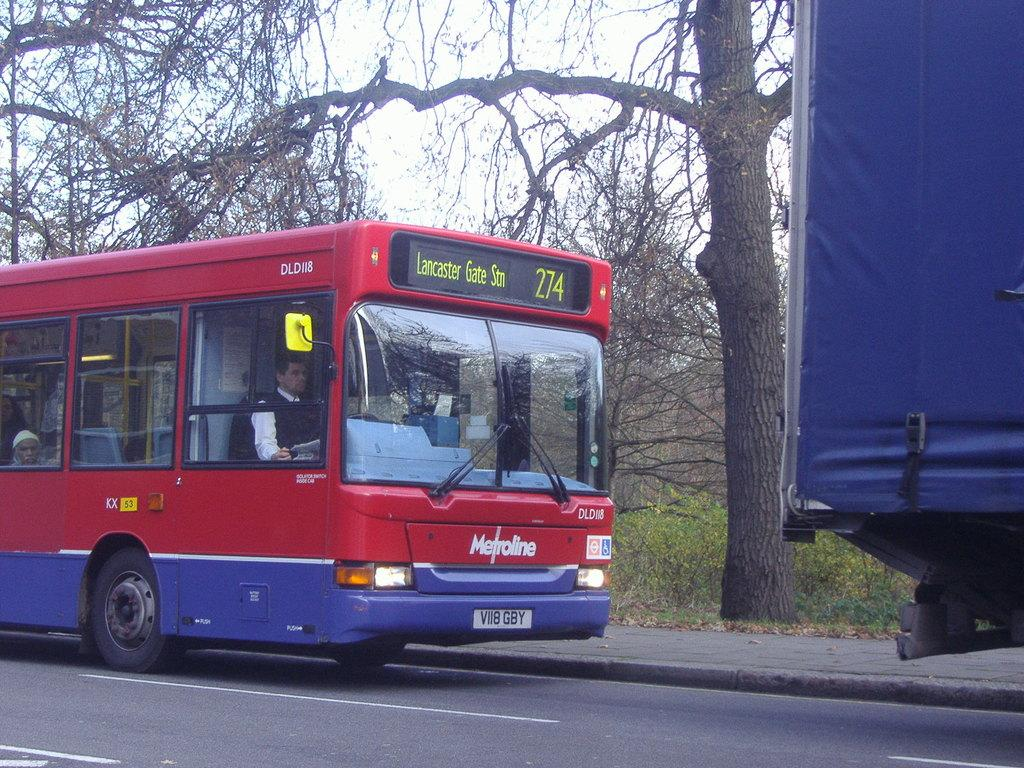What are the people in the image doing? The people in the image are riding a bus. Where is the bus located in the image? The bus is on the road. What can be seen on the right side of the image? There is a blue color object on the right side of the image. What is visible in the background of the image? In the background of the image, there is a walkway, trees, plants, and the sky. How many pairs of underwear are visible in the image? There are no underwear visible in the image. How many chickens can be seen running along the walkway in the background? There are no chickens present in the image. 